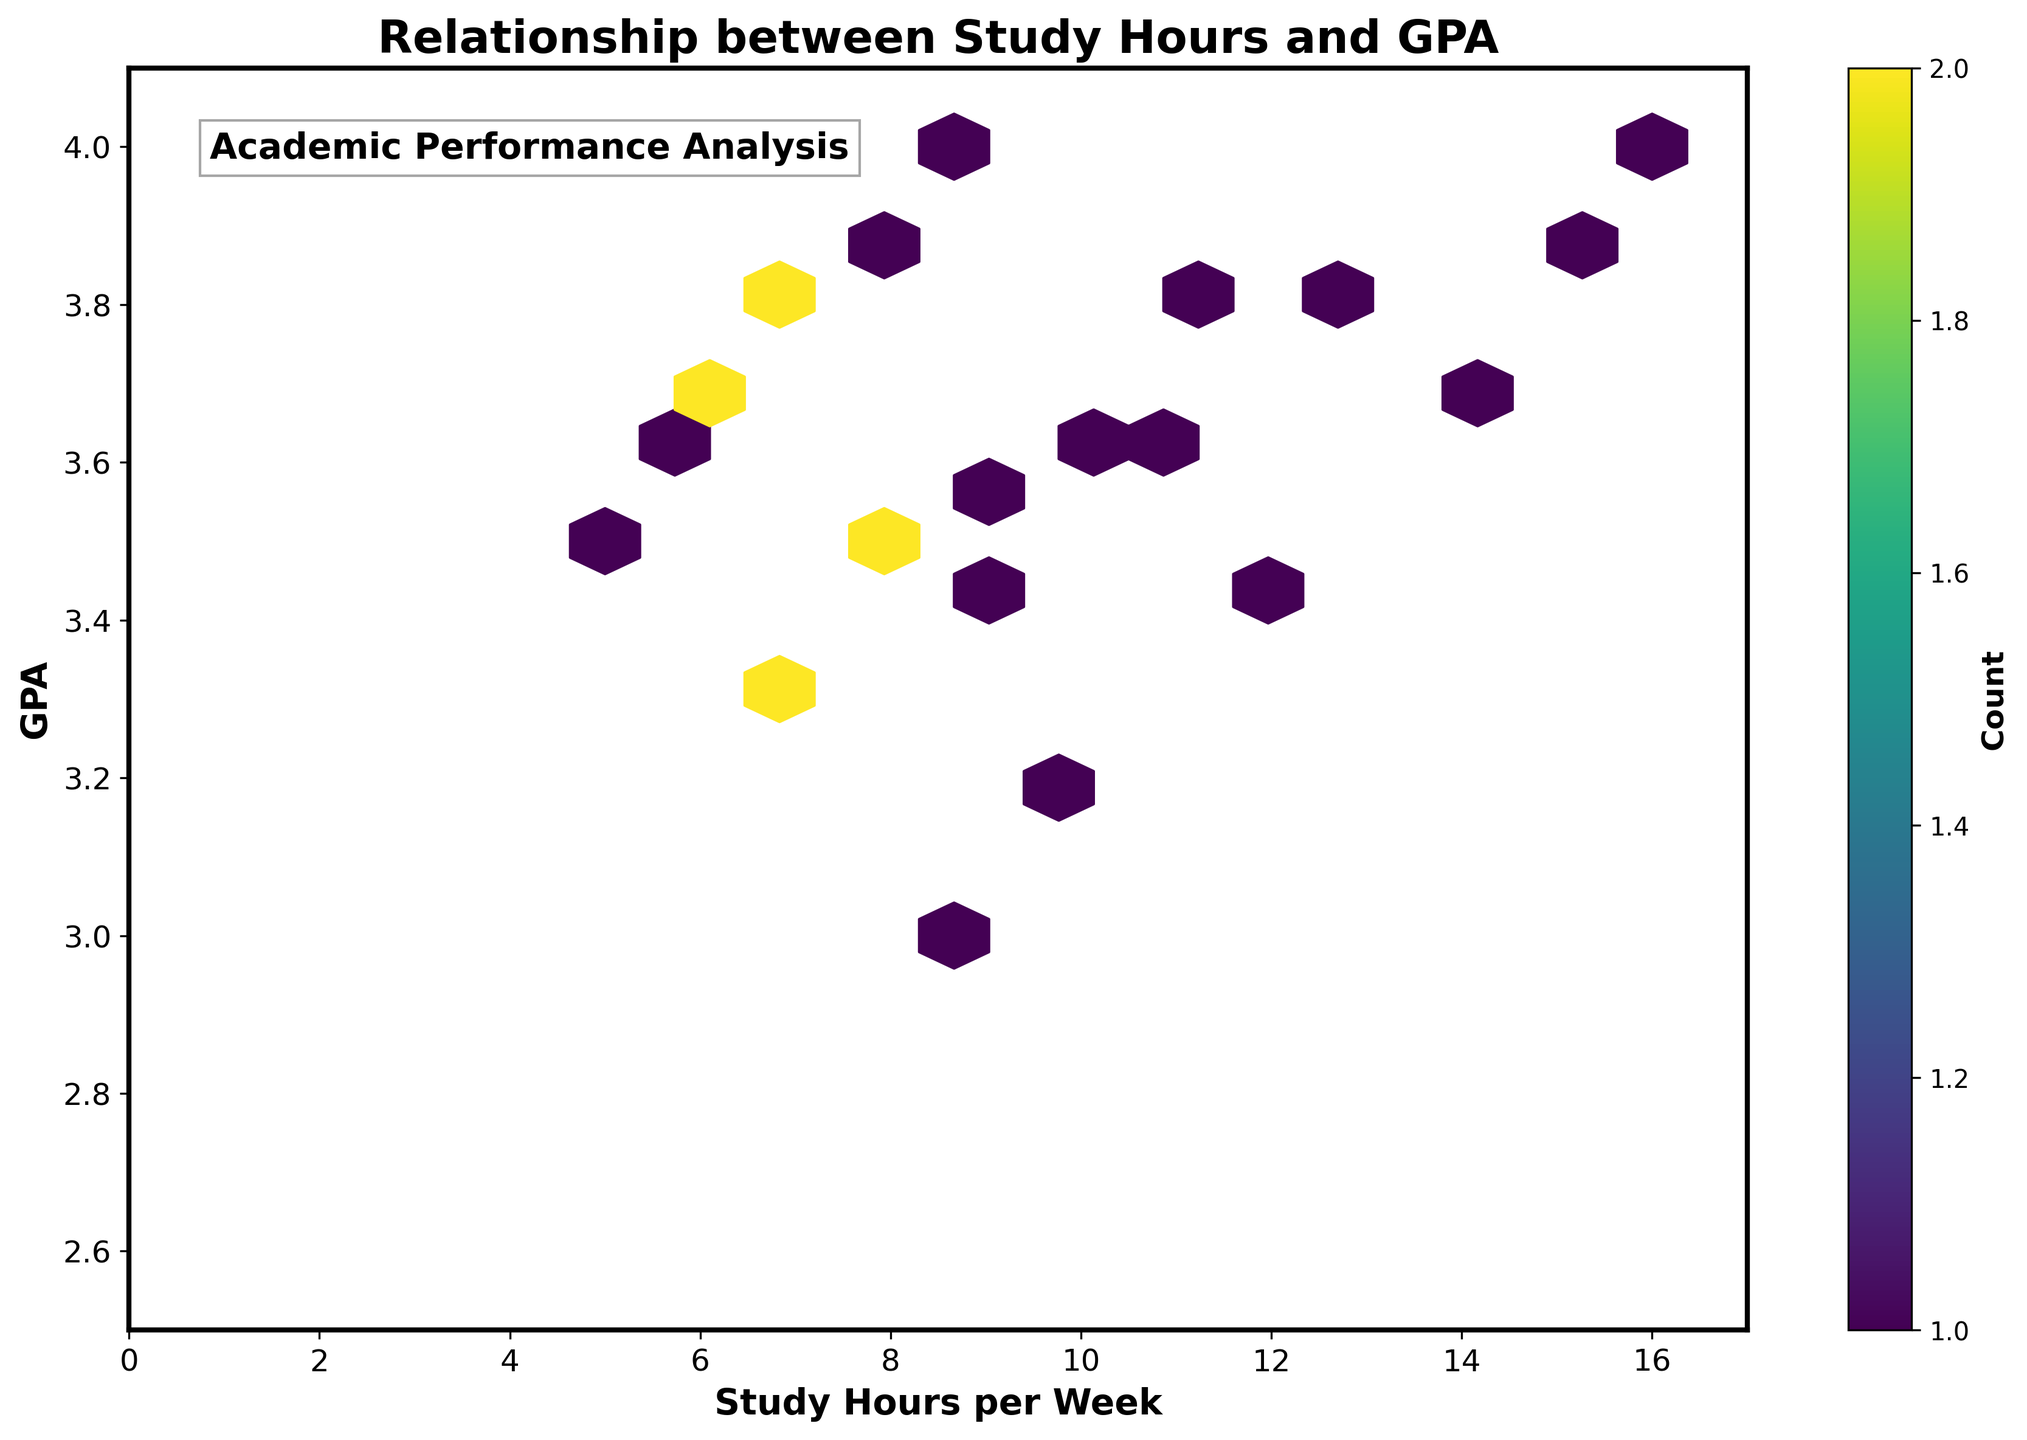What is the title of the hexbin plot? The title of the plot is stated at the top, usually in a larger font size for emphasis.
Answer: Relationship between Study Hours and GPA What do the X and Y axes represent? The labels on the X and Y axes describe what they measure. The X-axis label is 'Study Hours per Week', and the Y-axis label is 'GPA'.
Answer: Study Hours per Week and GPA Which area has the highest concentration of data points? The area with the highest concentration of data points can be identified by the darkest hexagons in the plot. These hexagons have the highest count of overlapping points.
Answer: Around 9-10 study hours per week and a GPA of approximately 3.5 How does GPA generally change as study hours per week increase? Observing the trend in the plot, you see that as you move from left to right (increasing study hours), the GPA seems to increase.
Answer: GPA generally increases What are the lowest and highest GPAs shown on the plot? The top and bottom bounds of the Y-axis indicate the range of GPAs. The Y-axis limits are from 2.5 to 4.1.
Answer: 2.5 (lowest) and 4.0 (highest) How does the density of data points vary with study hours per week below and above 10 hours? The hexbin plot shows denser clusters of points around certain values. Below 10 hours, there is a higher density compared to above 10 hours, where the density seems to spread out.
Answer: Denser below 10 hours, more spread out above 10 hours Between which range of study hours is the GPA the most varied? The most varied GPA will be observed where the hexbin cells cover a wide range of GPA values. This can be seen around study hours ranging from about 6 to 10 hours per week.
Answer: 6 to 10 study hours How does the color bar help interpret the data in the hexbin plot? The color bar to the right of the plot shows a gradient indicating the count of data points in each hexagon, helping with understanding the density of data across the plot.
Answer: Indicates density of data points What does the text box at the top left of the plot display? The text box contains an annotation that helps contextualize or provide additional information about the plot.
Answer: Academic Performance Analysis What is the relationship between the number of study hours per week and GPA for study hours between 12 and 16 hours? Observing the hexagons plotted between 12 and 16 study hours per week, the GPA falls between 3.4 to 4.0, indicating an increasing trend.
Answer: Increasing trend 